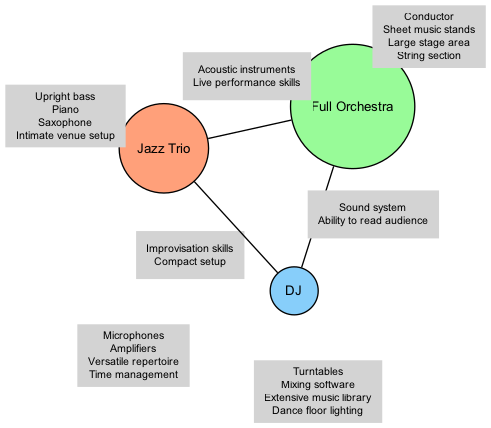What unique equipment is found in a Jazz Trio? The unique equipment for a Jazz Trio includes an upright bass, piano, saxophone, and an intimate venue setup, as listed under the Jazz Trio section of the diagram.
Answer: Upright bass, piano, saxophone, intimate venue setup What skills are shared between Jazz Trio and Full Orchestra? The skills shared between a Jazz Trio and a Full Orchestra include acoustic instruments and live performance skills, which are found in the intersection of these two sets in the diagram.
Answer: Acoustic instruments, live performance skills How many unique elements are associated with the DJ? The DJ has four unique elements: turntables, mixing software, extensive music library, and dance floor lighting. This can be counted directly from the DJ section of the diagram.
Answer: 4 Which type of band requires a conductor? The Full Orchestra requires a conductor, as it is specified as a unique element directly associated with this band type in the diagram.
Answer: Full Orchestra What common elements do all three band types share? All three band types share microphones, amplifiers, versatile repertoire, and time management in the center intersection of the diagram, indicating elements common to the Jazz Trio, Full Orchestra, and DJ.
Answer: Microphones, amplifiers, versatile repertoire, time management What is the only unique element of the Full Orchestra? The unique elements of the Full Orchestra are conductor, sheet music stands, large stage area, and string section, but since the question asks for the only unique element, the answer indicates that all these items are unique to them and not shared.
Answer: Conductor, sheet music stands, large stage area, string section Which band type is associated with dance floor lighting? The DJ is associated with dance floor lighting, which is one of the unique elements clearly outlined under the DJ category in the diagram.
Answer: DJ What items are shared between the DJ and Jazz Trio? The DJ and Jazz Trio share improvisation skills and a compact setup according to the intersection identified in the diagram.
Answer: Improvisation skills, compact setup How many intersections are shown in the diagram? The diagram features four intersections: between Jazz Trio and Full Orchestra, Full Orchestra and DJ, Jazz Trio and DJ, and among all three band types. Counting each of these gives the total number of intersections.
Answer: 4 